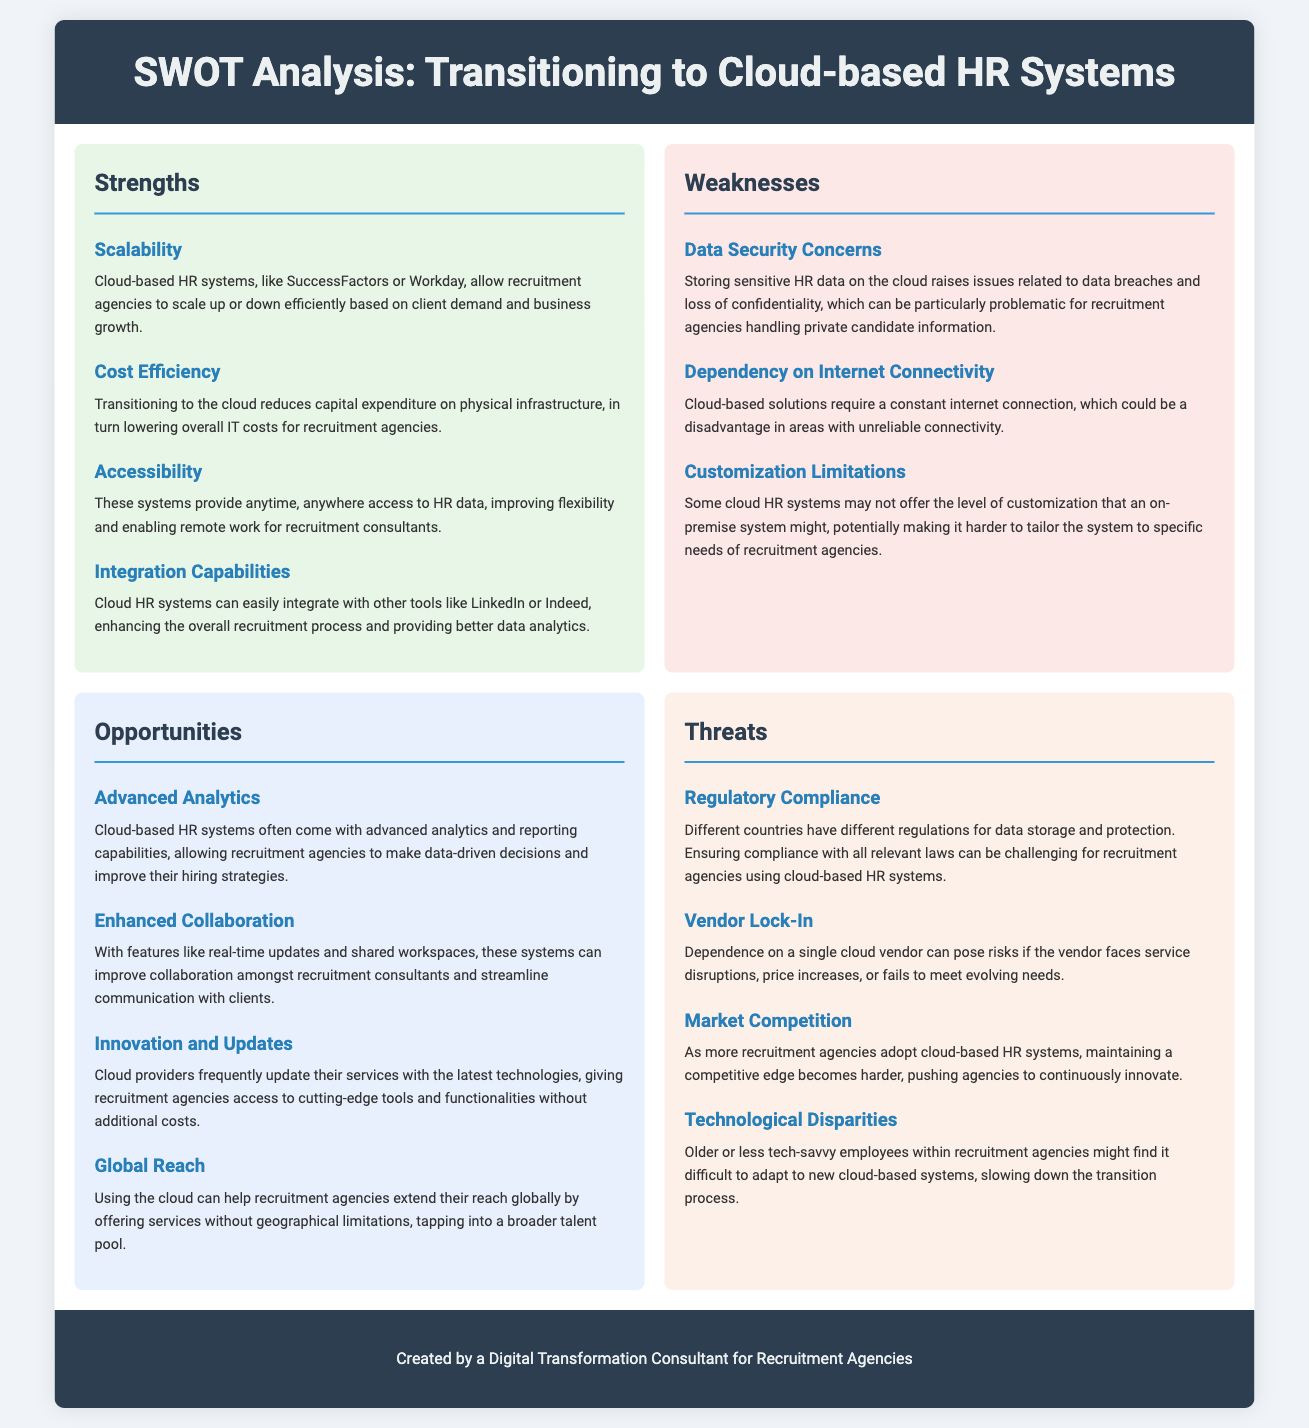What are two strengths of transitioning to cloud-based HR systems? The strengths of transitioning to cloud-based HR systems include scalability and cost efficiency, as mentioned in the Strengths section of the document.
Answer: Scalability, cost efficiency What is one opportunity mentioned in the document? The document lists advanced analytics as one of the opportunities for recruitment agencies transitioning to cloud-based HR systems.
Answer: Advanced analytics What is a weakness related to cloud HR systems? The weakness highlighted in the document includes data security concerns, which can affect recruitment agencies due to the sensitive nature of their information.
Answer: Data security concerns What is the title of the document? The title of the document appears at the top of the rendered page, stating the focus on SWOT Analysis for HR systems.
Answer: SWOT Analysis: Transitioning to Cloud-based HR Systems What is one threat mentioned in the document? According to the Threats section, regulatory compliance is one of the threats faced by recruitment agencies using cloud-based HR systems.
Answer: Regulatory compliance What benefit is emphasized under accessibility? The document mentions that cloud-based HR systems provide anytime, anywhere access to HR data, improving flexibility for remote work.
Answer: Anytime, anywhere access How many strengths are listed in the document? The document enumerates four distinct strengths within the Strengths section.
Answer: Four What limitation is indicated regarding customization? The document notes that some cloud HR systems may not offer the level of customization that an on-premise system might.
Answer: Customization limitations 